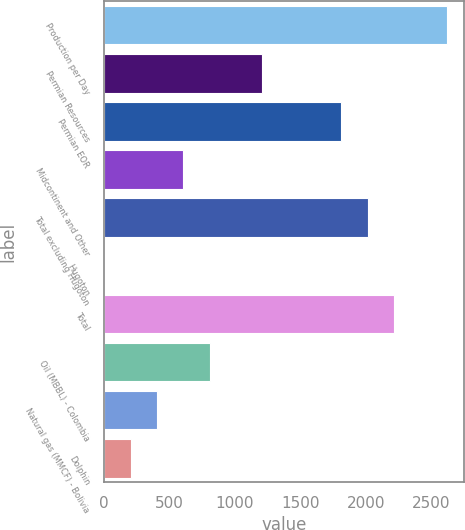Convert chart. <chart><loc_0><loc_0><loc_500><loc_500><bar_chart><fcel>Production per Day<fcel>Permian Resources<fcel>Permian EOR<fcel>Midcontinent and Other<fcel>Total excluding Hugoton<fcel>Hugoton<fcel>Total<fcel>Oil (MBBL) - Colombia<fcel>Natural gas (MMCF) - Bolivia<fcel>Dolphin<nl><fcel>2617.6<fcel>1209.2<fcel>1812.8<fcel>605.6<fcel>2014<fcel>2<fcel>2215.2<fcel>806.8<fcel>404.4<fcel>203.2<nl></chart> 